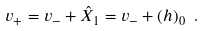<formula> <loc_0><loc_0><loc_500><loc_500>v _ { + } = v _ { - } + \hat { X } _ { 1 } = v _ { - } + ( h ) _ { 0 } \ .</formula> 